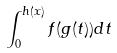<formula> <loc_0><loc_0><loc_500><loc_500>\int _ { 0 } ^ { h ( x ) } f ( g ( t ) ) d t</formula> 